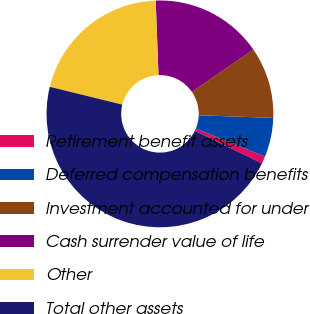<chart> <loc_0><loc_0><loc_500><loc_500><pie_chart><fcel>Retirement benefit assets<fcel>Deferred compensation benefits<fcel>Investment accounted for under<fcel>Cash surrender value of life<fcel>Other<fcel>Total other assets<nl><fcel>1.03%<fcel>5.59%<fcel>10.15%<fcel>16.01%<fcel>20.57%<fcel>46.64%<nl></chart> 